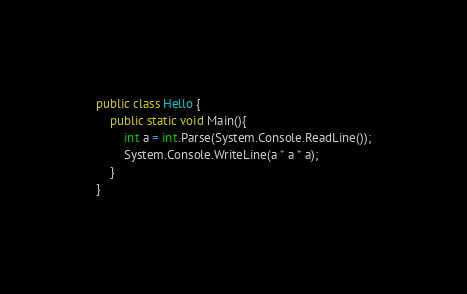Convert code to text. <code><loc_0><loc_0><loc_500><loc_500><_C#_>public class Hello {
    public static void Main(){
        int a = int.Parse(System.Console.ReadLine());
        System.Console.WriteLine(a * a * a);
    }
}

</code> 